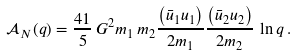<formula> <loc_0><loc_0><loc_500><loc_500>\mathcal { A } _ { N } ( q ) = \frac { 4 1 } { 5 } \, G ^ { 2 } { m _ { 1 } } \, { m _ { 2 } } \frac { \left ( \bar { u } _ { 1 } u _ { 1 } \right ) } { 2 m _ { 1 } } \frac { \left ( \bar { u } _ { 2 } u _ { 2 } \right ) } { 2 m _ { 2 } } \, \ln q \, .</formula> 